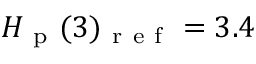Convert formula to latex. <formula><loc_0><loc_0><loc_500><loc_500>H _ { p } ( 3 ) _ { r e f } = 3 . 4</formula> 